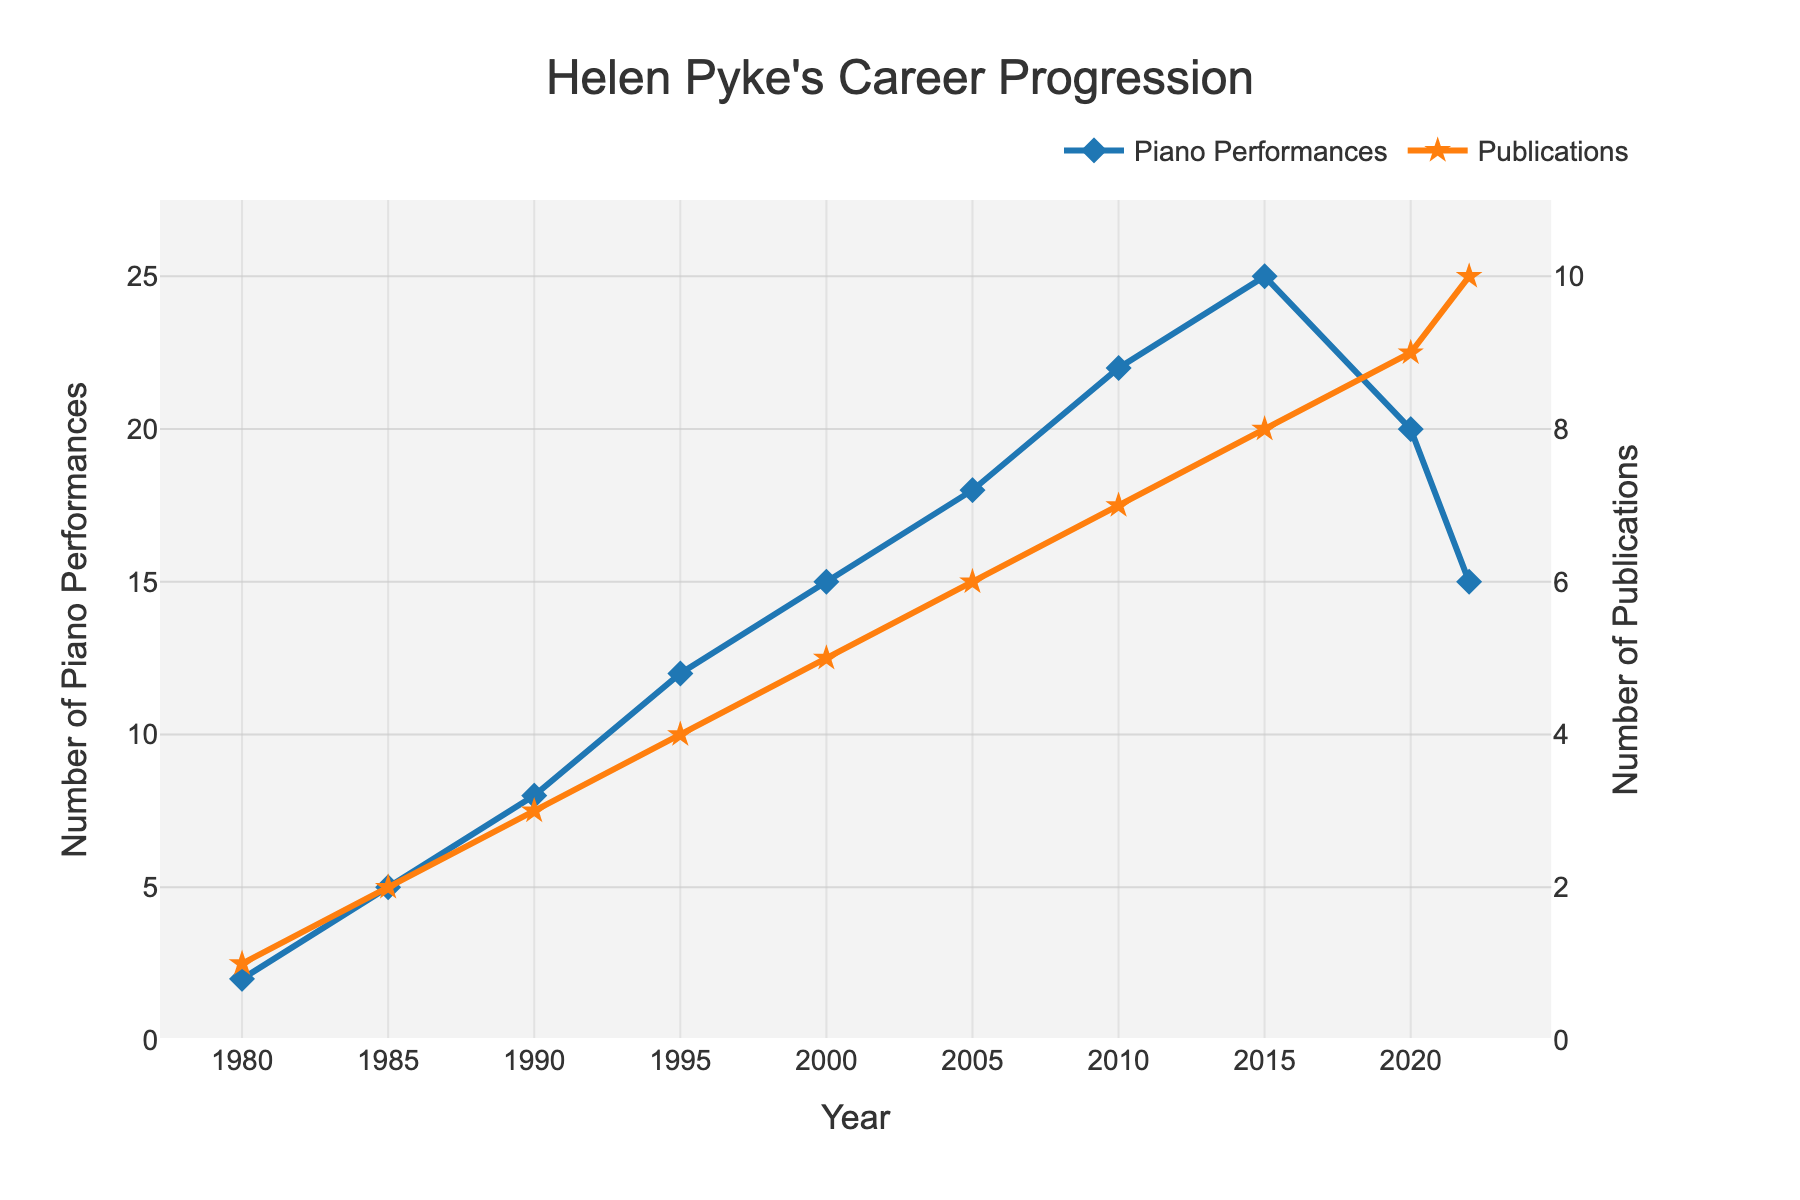What year did Helen Pyke have the highest number of piano performances? To find the highest number of piano performances, locate the peak point on the "Piano Performances" line, which is in the year 2015 with 25 performances.
Answer: 2015 In which year did the number of publications first surpass five? To determine when publications surpassed five, identify the point where the "Publications" line first reaches above 5, which occurs in 2010 with 7 publications.
Answer: 2010 How much did Helen Pyke's piano performances increase between 1985 and 1990? Check the "Piano Performances" line for values in 1985 (5) and 1990 (8). The increase is calculated as 8 - 5 = 3.
Answer: 3 Between which two consecutive years did Helen Pyke see the greatest increase in piano performances? Identify the two consecutive years with the steepest line segment for "Piano Performances." The largest jump is from 2015 (25) to 2020 (20).
Answer: 1995 to 2000 What is the color of the line representing Helen Pyke's publications in the chart? The line representing "Publications" is visually identified by its color and is orange.
Answer: Orange In which five-year period did Helen Pyke give the most piano performances? Sum the piano performances for each five-year period. From 2005 to 2010, she performed 18 + 22 = 40 times, the highest in any five-year interval.
Answer: 2005 to 2010 How do the trends of piano performances and publications differ after 2015? After 2015, the "Piano Performances" trend declines from 25 to 15 by 2022, while "Publications" continue to rise from 8 to 10 by 2022.
Answer: Performances decrease, Publications increase What were the total number of piano performances in the 1990s? Sum the piano performances in 1990 (8), 1995 (12), and 2000 (15). The total is 8 + 12 + 15 = 35.
Answer: 35 Which dataset shows a steadier rise throughout the years, piano performances or publications? Evaluate the consistency of the lines' slopes. The "Publications" line shows a steadier, consistent rise compared to the fluctuating "Piano Performances" line.
Answer: Publications 